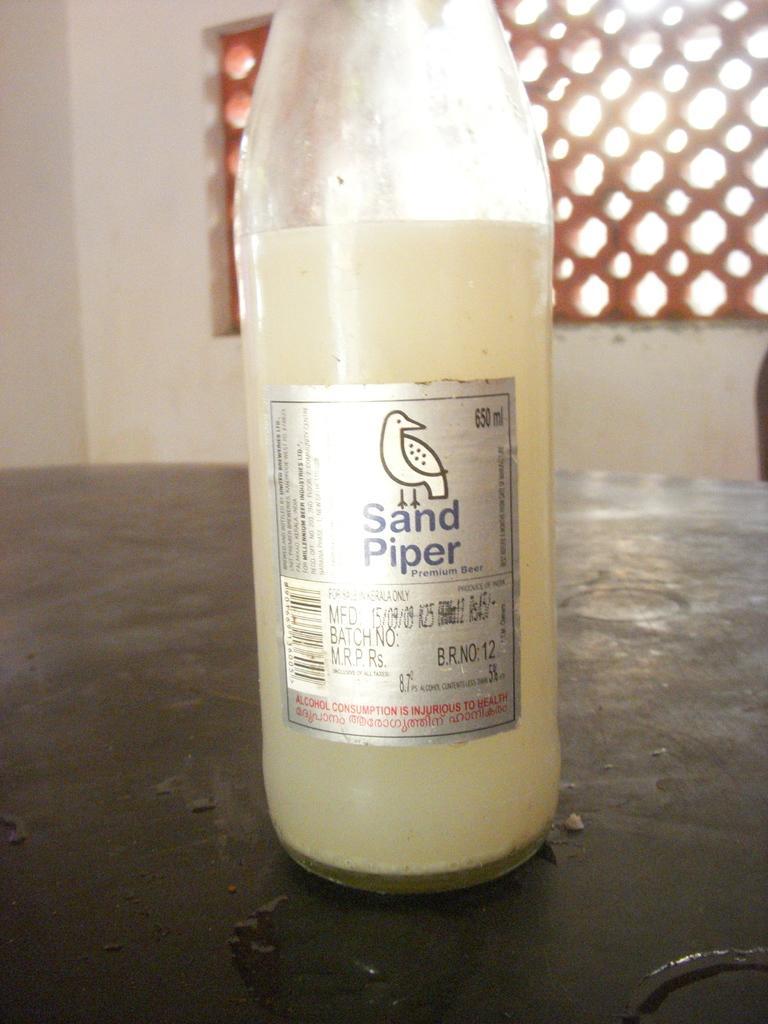Please provide a concise description of this image. In this image I can see a bottle placed on the table. It looks like a beer bottle with a label attached to it. On this label I can see a bird and sandpiper is written on it. At background I can see a wall with a window. 